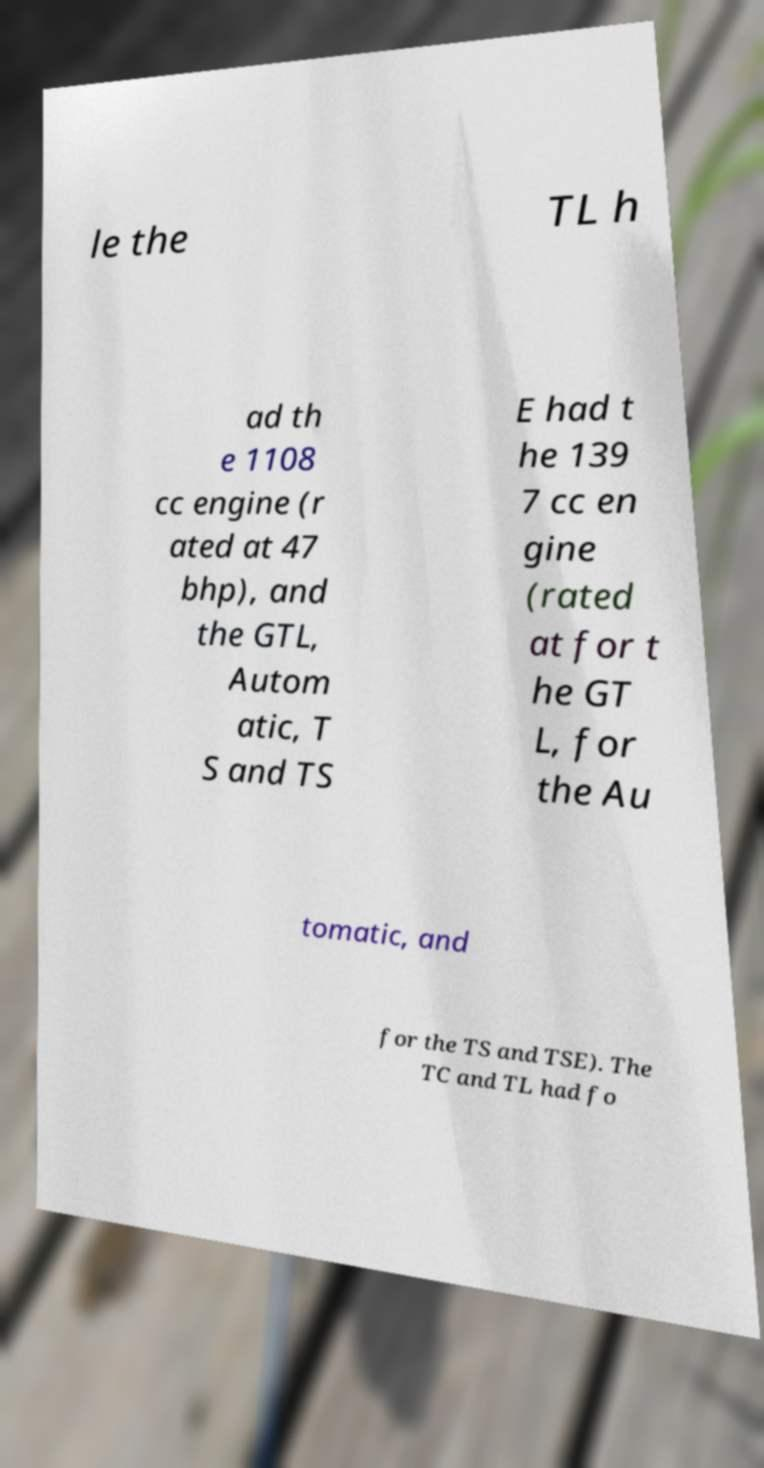What messages or text are displayed in this image? I need them in a readable, typed format. le the TL h ad th e 1108 cc engine (r ated at 47 bhp), and the GTL, Autom atic, T S and TS E had t he 139 7 cc en gine (rated at for t he GT L, for the Au tomatic, and for the TS and TSE). The TC and TL had fo 